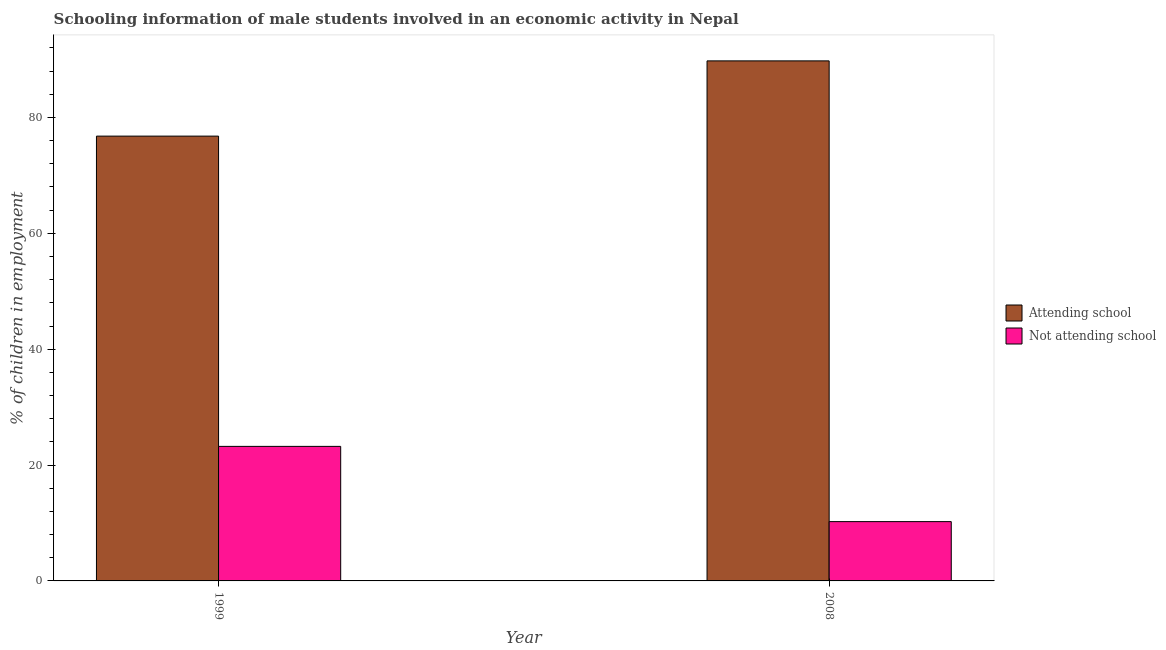How many bars are there on the 1st tick from the left?
Your answer should be compact. 2. What is the label of the 1st group of bars from the left?
Provide a short and direct response. 1999. In how many cases, is the number of bars for a given year not equal to the number of legend labels?
Give a very brief answer. 0. What is the percentage of employed males who are not attending school in 1999?
Your response must be concise. 23.22. Across all years, what is the maximum percentage of employed males who are attending school?
Your answer should be very brief. 89.76. Across all years, what is the minimum percentage of employed males who are not attending school?
Provide a succinct answer. 10.24. What is the total percentage of employed males who are attending school in the graph?
Offer a very short reply. 166.54. What is the difference between the percentage of employed males who are not attending school in 1999 and that in 2008?
Make the answer very short. 12.99. What is the difference between the percentage of employed males who are not attending school in 2008 and the percentage of employed males who are attending school in 1999?
Make the answer very short. -12.99. What is the average percentage of employed males who are attending school per year?
Your answer should be compact. 83.27. In the year 2008, what is the difference between the percentage of employed males who are not attending school and percentage of employed males who are attending school?
Offer a terse response. 0. In how many years, is the percentage of employed males who are not attending school greater than 44 %?
Give a very brief answer. 0. What is the ratio of the percentage of employed males who are attending school in 1999 to that in 2008?
Make the answer very short. 0.86. What does the 1st bar from the left in 2008 represents?
Offer a very short reply. Attending school. What does the 1st bar from the right in 2008 represents?
Offer a terse response. Not attending school. Are all the bars in the graph horizontal?
Keep it short and to the point. No. What is the difference between two consecutive major ticks on the Y-axis?
Ensure brevity in your answer.  20. Does the graph contain any zero values?
Make the answer very short. No. How many legend labels are there?
Your response must be concise. 2. What is the title of the graph?
Keep it short and to the point. Schooling information of male students involved in an economic activity in Nepal. Does "Female" appear as one of the legend labels in the graph?
Offer a terse response. No. What is the label or title of the X-axis?
Offer a very short reply. Year. What is the label or title of the Y-axis?
Your answer should be compact. % of children in employment. What is the % of children in employment in Attending school in 1999?
Offer a terse response. 76.78. What is the % of children in employment of Not attending school in 1999?
Your response must be concise. 23.22. What is the % of children in employment in Attending school in 2008?
Your answer should be compact. 89.76. What is the % of children in employment in Not attending school in 2008?
Keep it short and to the point. 10.24. Across all years, what is the maximum % of children in employment of Attending school?
Your answer should be compact. 89.76. Across all years, what is the maximum % of children in employment of Not attending school?
Keep it short and to the point. 23.22. Across all years, what is the minimum % of children in employment in Attending school?
Your answer should be compact. 76.78. Across all years, what is the minimum % of children in employment in Not attending school?
Give a very brief answer. 10.24. What is the total % of children in employment in Attending school in the graph?
Provide a succinct answer. 166.54. What is the total % of children in employment in Not attending school in the graph?
Your answer should be very brief. 33.46. What is the difference between the % of children in employment of Attending school in 1999 and that in 2008?
Your answer should be very brief. -12.99. What is the difference between the % of children in employment of Not attending school in 1999 and that in 2008?
Your answer should be compact. 12.99. What is the difference between the % of children in employment of Attending school in 1999 and the % of children in employment of Not attending school in 2008?
Your answer should be compact. 66.54. What is the average % of children in employment in Attending school per year?
Offer a very short reply. 83.27. What is the average % of children in employment in Not attending school per year?
Offer a very short reply. 16.73. In the year 1999, what is the difference between the % of children in employment in Attending school and % of children in employment in Not attending school?
Offer a very short reply. 53.55. In the year 2008, what is the difference between the % of children in employment of Attending school and % of children in employment of Not attending school?
Keep it short and to the point. 79.53. What is the ratio of the % of children in employment in Attending school in 1999 to that in 2008?
Give a very brief answer. 0.86. What is the ratio of the % of children in employment of Not attending school in 1999 to that in 2008?
Offer a terse response. 2.27. What is the difference between the highest and the second highest % of children in employment in Attending school?
Provide a succinct answer. 12.99. What is the difference between the highest and the second highest % of children in employment of Not attending school?
Your answer should be compact. 12.99. What is the difference between the highest and the lowest % of children in employment in Attending school?
Ensure brevity in your answer.  12.99. What is the difference between the highest and the lowest % of children in employment of Not attending school?
Make the answer very short. 12.99. 